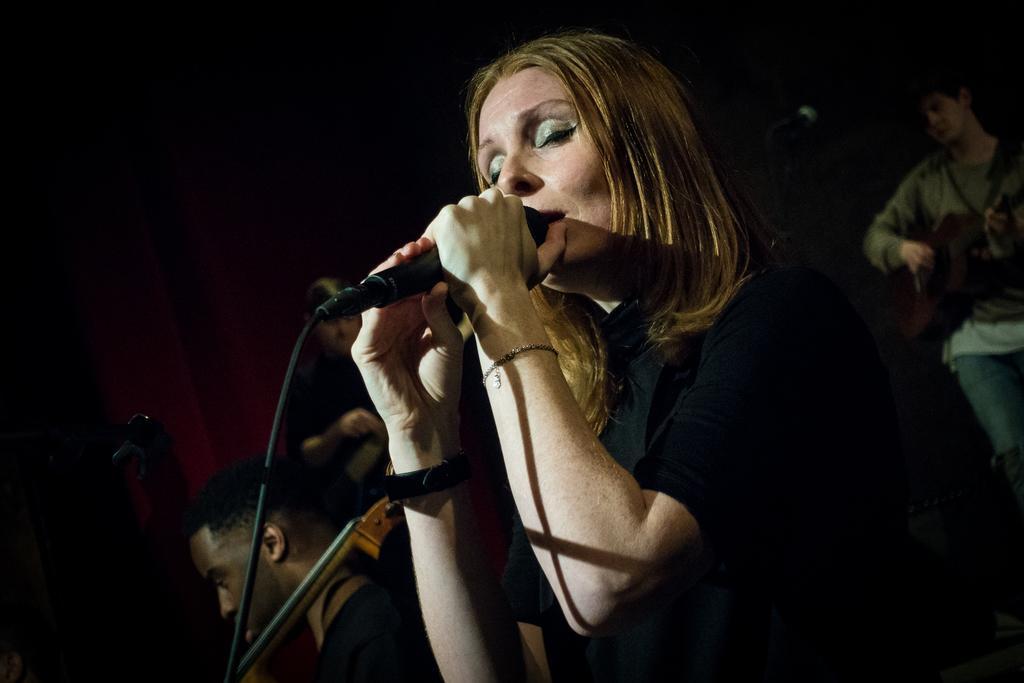How would you summarize this image in a sentence or two? In this picture there is a lady in the center of the image, by holding a mic in her hands and there are other people in the background area of the image. 